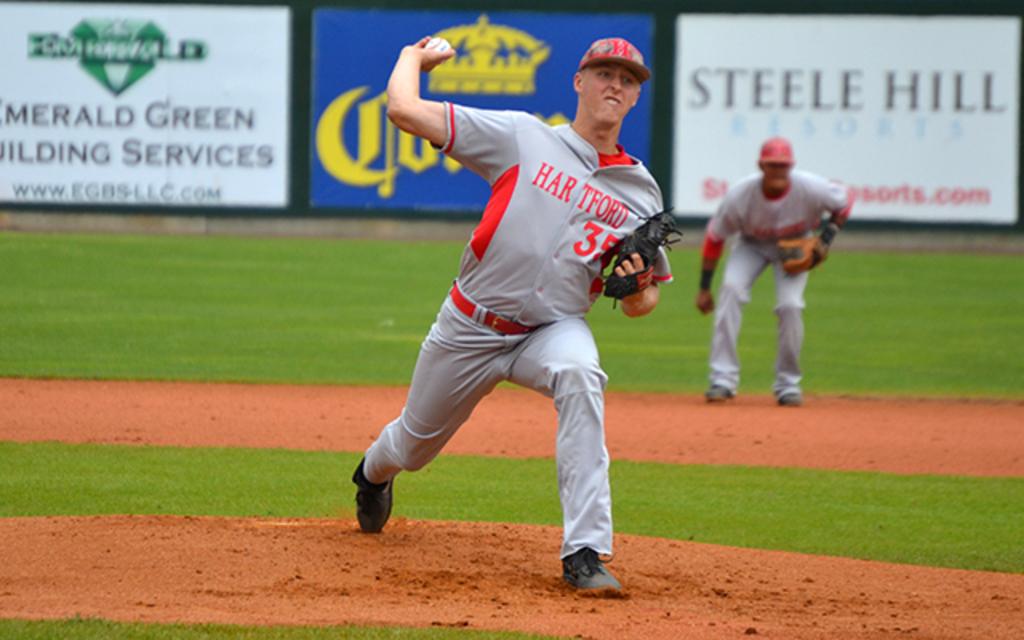What player number is the pitcher?
Make the answer very short. 35. 